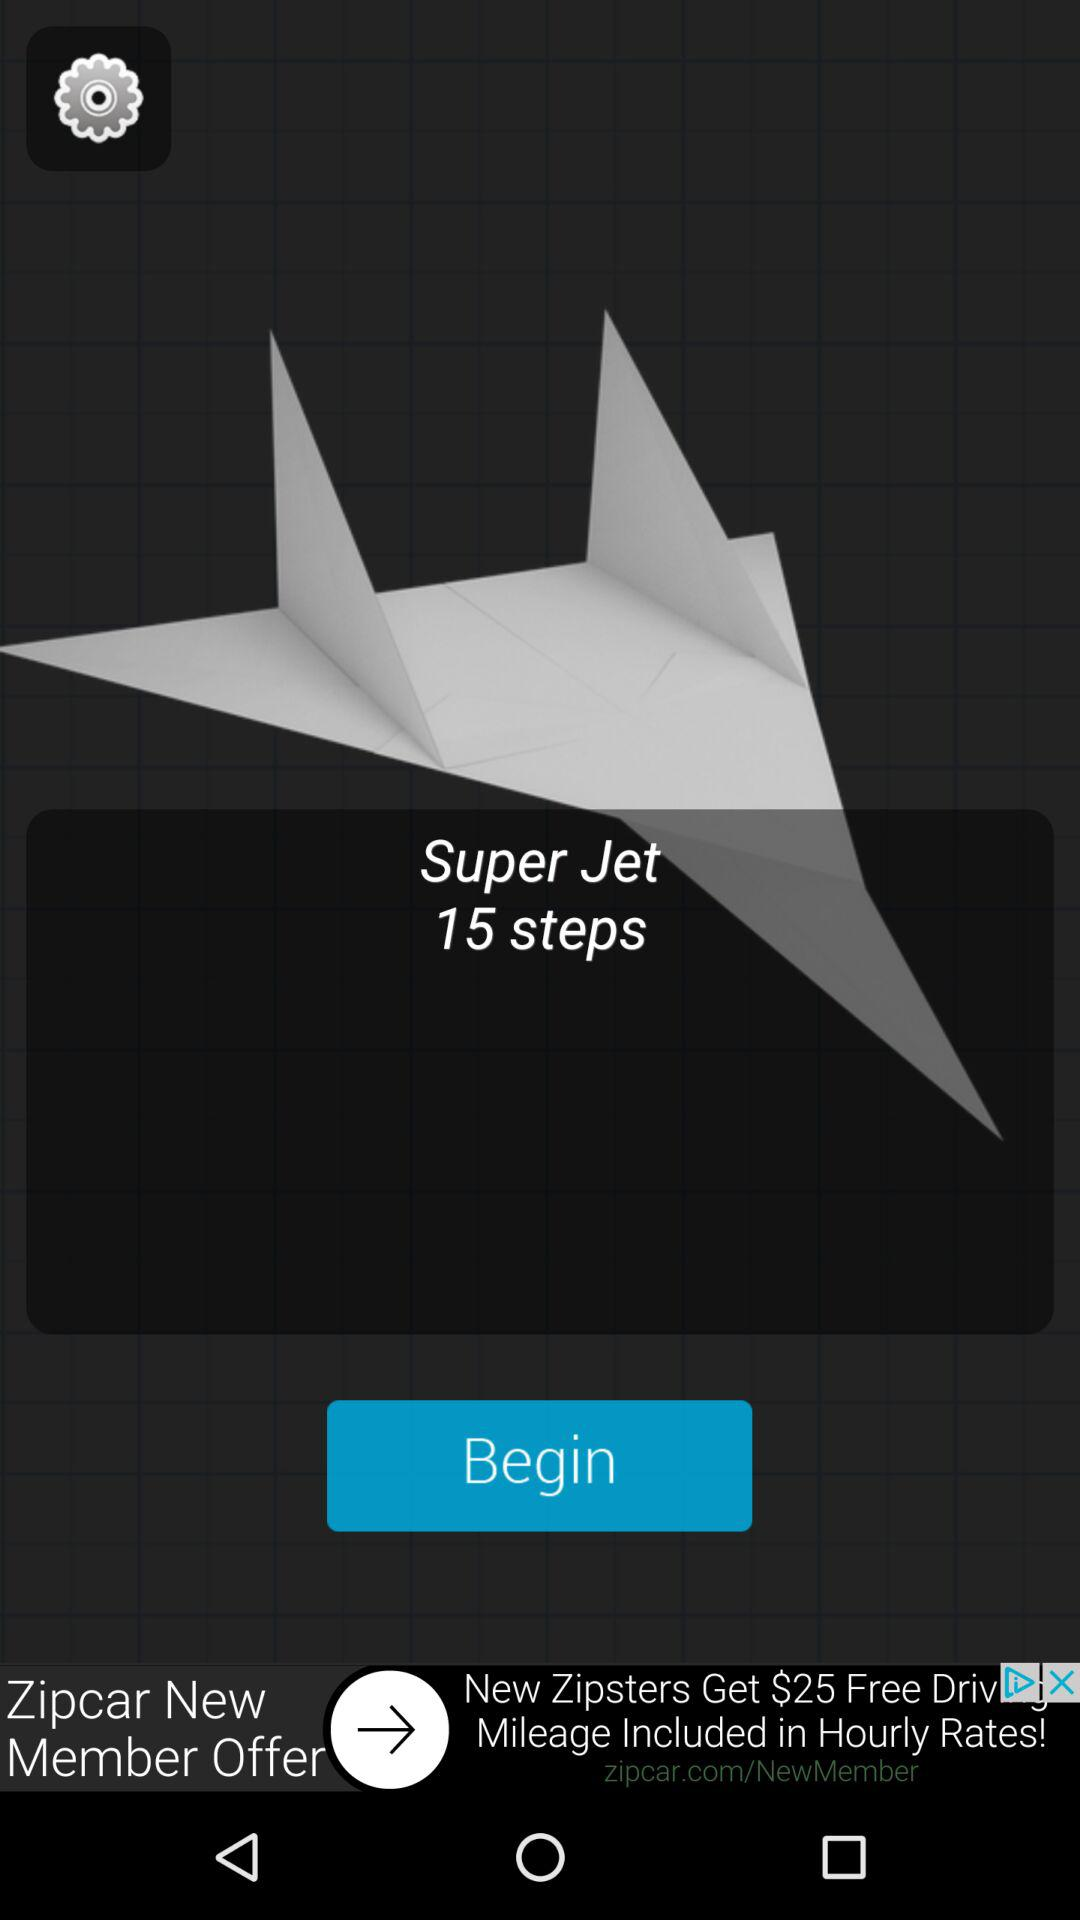What is the name of the application? The application name is "Super Jet". 